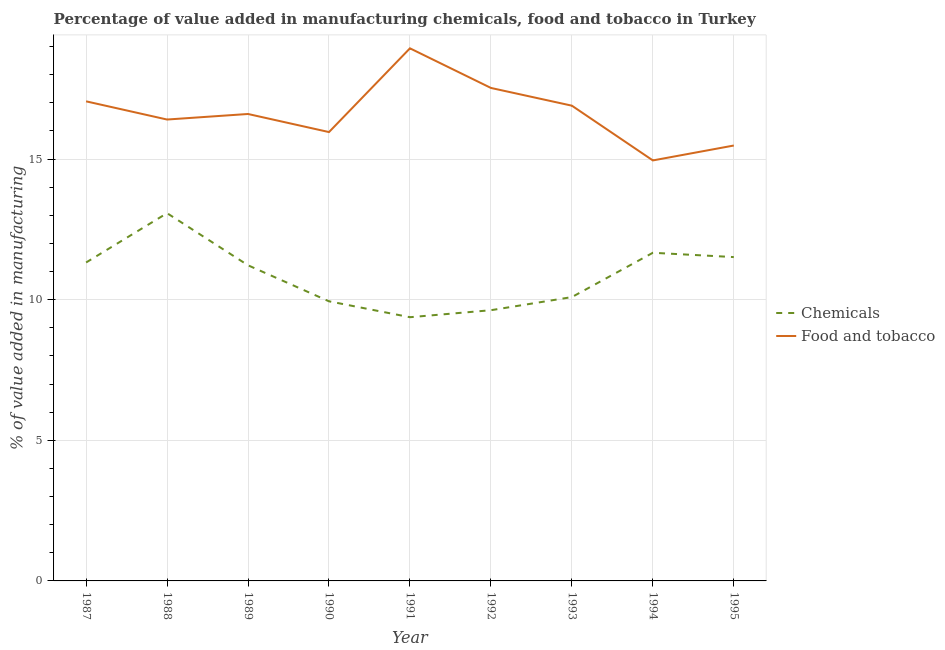Is the number of lines equal to the number of legend labels?
Ensure brevity in your answer.  Yes. What is the value added by manufacturing food and tobacco in 1990?
Your response must be concise. 15.96. Across all years, what is the maximum value added by manufacturing food and tobacco?
Make the answer very short. 18.94. Across all years, what is the minimum value added by manufacturing food and tobacco?
Make the answer very short. 14.95. In which year was the value added by  manufacturing chemicals maximum?
Your answer should be very brief. 1988. What is the total value added by  manufacturing chemicals in the graph?
Make the answer very short. 97.83. What is the difference between the value added by manufacturing food and tobacco in 1994 and that in 1995?
Ensure brevity in your answer.  -0.53. What is the difference between the value added by  manufacturing chemicals in 1990 and the value added by manufacturing food and tobacco in 1988?
Provide a short and direct response. -6.46. What is the average value added by  manufacturing chemicals per year?
Make the answer very short. 10.87. In the year 1995, what is the difference between the value added by manufacturing food and tobacco and value added by  manufacturing chemicals?
Give a very brief answer. 3.97. In how many years, is the value added by  manufacturing chemicals greater than 9 %?
Your answer should be very brief. 9. What is the ratio of the value added by  manufacturing chemicals in 1993 to that in 1994?
Offer a very short reply. 0.86. Is the value added by manufacturing food and tobacco in 1987 less than that in 1994?
Make the answer very short. No. What is the difference between the highest and the second highest value added by  manufacturing chemicals?
Offer a very short reply. 1.41. What is the difference between the highest and the lowest value added by manufacturing food and tobacco?
Your answer should be compact. 3.99. How many lines are there?
Give a very brief answer. 2. How many years are there in the graph?
Ensure brevity in your answer.  9. What is the difference between two consecutive major ticks on the Y-axis?
Your answer should be compact. 5. Are the values on the major ticks of Y-axis written in scientific E-notation?
Give a very brief answer. No. Does the graph contain grids?
Ensure brevity in your answer.  Yes. Where does the legend appear in the graph?
Give a very brief answer. Center right. How are the legend labels stacked?
Offer a very short reply. Vertical. What is the title of the graph?
Your response must be concise. Percentage of value added in manufacturing chemicals, food and tobacco in Turkey. What is the label or title of the X-axis?
Provide a succinct answer. Year. What is the label or title of the Y-axis?
Ensure brevity in your answer.  % of value added in manufacturing. What is the % of value added in manufacturing of Chemicals in 1987?
Provide a short and direct response. 11.32. What is the % of value added in manufacturing of Food and tobacco in 1987?
Offer a terse response. 17.05. What is the % of value added in manufacturing of Chemicals in 1988?
Ensure brevity in your answer.  13.08. What is the % of value added in manufacturing in Food and tobacco in 1988?
Your response must be concise. 16.4. What is the % of value added in manufacturing of Chemicals in 1989?
Your answer should be very brief. 11.22. What is the % of value added in manufacturing of Food and tobacco in 1989?
Provide a short and direct response. 16.6. What is the % of value added in manufacturing in Chemicals in 1990?
Your answer should be very brief. 9.94. What is the % of value added in manufacturing of Food and tobacco in 1990?
Provide a short and direct response. 15.96. What is the % of value added in manufacturing of Chemicals in 1991?
Offer a very short reply. 9.38. What is the % of value added in manufacturing in Food and tobacco in 1991?
Provide a short and direct response. 18.94. What is the % of value added in manufacturing of Chemicals in 1992?
Offer a very short reply. 9.63. What is the % of value added in manufacturing of Food and tobacco in 1992?
Offer a very short reply. 17.53. What is the % of value added in manufacturing in Chemicals in 1993?
Offer a terse response. 10.09. What is the % of value added in manufacturing in Food and tobacco in 1993?
Give a very brief answer. 16.9. What is the % of value added in manufacturing of Chemicals in 1994?
Give a very brief answer. 11.67. What is the % of value added in manufacturing in Food and tobacco in 1994?
Offer a terse response. 14.95. What is the % of value added in manufacturing of Chemicals in 1995?
Your answer should be very brief. 11.51. What is the % of value added in manufacturing in Food and tobacco in 1995?
Your answer should be compact. 15.48. Across all years, what is the maximum % of value added in manufacturing of Chemicals?
Your response must be concise. 13.08. Across all years, what is the maximum % of value added in manufacturing of Food and tobacco?
Your answer should be very brief. 18.94. Across all years, what is the minimum % of value added in manufacturing of Chemicals?
Ensure brevity in your answer.  9.38. Across all years, what is the minimum % of value added in manufacturing in Food and tobacco?
Your answer should be very brief. 14.95. What is the total % of value added in manufacturing of Chemicals in the graph?
Your response must be concise. 97.83. What is the total % of value added in manufacturing of Food and tobacco in the graph?
Offer a very short reply. 149.81. What is the difference between the % of value added in manufacturing in Chemicals in 1987 and that in 1988?
Your answer should be very brief. -1.75. What is the difference between the % of value added in manufacturing in Food and tobacco in 1987 and that in 1988?
Keep it short and to the point. 0.65. What is the difference between the % of value added in manufacturing of Chemicals in 1987 and that in 1989?
Give a very brief answer. 0.1. What is the difference between the % of value added in manufacturing of Food and tobacco in 1987 and that in 1989?
Provide a short and direct response. 0.45. What is the difference between the % of value added in manufacturing in Chemicals in 1987 and that in 1990?
Ensure brevity in your answer.  1.38. What is the difference between the % of value added in manufacturing in Food and tobacco in 1987 and that in 1990?
Your response must be concise. 1.09. What is the difference between the % of value added in manufacturing in Chemicals in 1987 and that in 1991?
Keep it short and to the point. 1.95. What is the difference between the % of value added in manufacturing in Food and tobacco in 1987 and that in 1991?
Your response must be concise. -1.88. What is the difference between the % of value added in manufacturing in Chemicals in 1987 and that in 1992?
Make the answer very short. 1.7. What is the difference between the % of value added in manufacturing in Food and tobacco in 1987 and that in 1992?
Give a very brief answer. -0.48. What is the difference between the % of value added in manufacturing in Chemicals in 1987 and that in 1993?
Your answer should be compact. 1.23. What is the difference between the % of value added in manufacturing of Food and tobacco in 1987 and that in 1993?
Ensure brevity in your answer.  0.15. What is the difference between the % of value added in manufacturing in Chemicals in 1987 and that in 1994?
Offer a very short reply. -0.35. What is the difference between the % of value added in manufacturing of Food and tobacco in 1987 and that in 1994?
Provide a short and direct response. 2.1. What is the difference between the % of value added in manufacturing of Chemicals in 1987 and that in 1995?
Ensure brevity in your answer.  -0.19. What is the difference between the % of value added in manufacturing in Food and tobacco in 1987 and that in 1995?
Provide a short and direct response. 1.57. What is the difference between the % of value added in manufacturing in Chemicals in 1988 and that in 1989?
Provide a succinct answer. 1.85. What is the difference between the % of value added in manufacturing of Food and tobacco in 1988 and that in 1989?
Offer a very short reply. -0.2. What is the difference between the % of value added in manufacturing of Chemicals in 1988 and that in 1990?
Give a very brief answer. 3.13. What is the difference between the % of value added in manufacturing of Food and tobacco in 1988 and that in 1990?
Offer a very short reply. 0.45. What is the difference between the % of value added in manufacturing of Chemicals in 1988 and that in 1991?
Provide a short and direct response. 3.7. What is the difference between the % of value added in manufacturing of Food and tobacco in 1988 and that in 1991?
Offer a very short reply. -2.53. What is the difference between the % of value added in manufacturing in Chemicals in 1988 and that in 1992?
Ensure brevity in your answer.  3.45. What is the difference between the % of value added in manufacturing of Food and tobacco in 1988 and that in 1992?
Provide a succinct answer. -1.12. What is the difference between the % of value added in manufacturing of Chemicals in 1988 and that in 1993?
Ensure brevity in your answer.  2.98. What is the difference between the % of value added in manufacturing of Food and tobacco in 1988 and that in 1993?
Your answer should be compact. -0.49. What is the difference between the % of value added in manufacturing of Chemicals in 1988 and that in 1994?
Keep it short and to the point. 1.41. What is the difference between the % of value added in manufacturing in Food and tobacco in 1988 and that in 1994?
Offer a very short reply. 1.45. What is the difference between the % of value added in manufacturing in Chemicals in 1988 and that in 1995?
Offer a very short reply. 1.56. What is the difference between the % of value added in manufacturing in Food and tobacco in 1988 and that in 1995?
Offer a very short reply. 0.92. What is the difference between the % of value added in manufacturing of Chemicals in 1989 and that in 1990?
Your answer should be compact. 1.28. What is the difference between the % of value added in manufacturing of Food and tobacco in 1989 and that in 1990?
Keep it short and to the point. 0.64. What is the difference between the % of value added in manufacturing of Chemicals in 1989 and that in 1991?
Offer a terse response. 1.85. What is the difference between the % of value added in manufacturing of Food and tobacco in 1989 and that in 1991?
Keep it short and to the point. -2.33. What is the difference between the % of value added in manufacturing in Chemicals in 1989 and that in 1992?
Your response must be concise. 1.6. What is the difference between the % of value added in manufacturing of Food and tobacco in 1989 and that in 1992?
Give a very brief answer. -0.93. What is the difference between the % of value added in manufacturing of Chemicals in 1989 and that in 1993?
Provide a short and direct response. 1.13. What is the difference between the % of value added in manufacturing in Food and tobacco in 1989 and that in 1993?
Keep it short and to the point. -0.3. What is the difference between the % of value added in manufacturing of Chemicals in 1989 and that in 1994?
Provide a succinct answer. -0.45. What is the difference between the % of value added in manufacturing of Food and tobacco in 1989 and that in 1994?
Make the answer very short. 1.65. What is the difference between the % of value added in manufacturing in Chemicals in 1989 and that in 1995?
Ensure brevity in your answer.  -0.29. What is the difference between the % of value added in manufacturing in Food and tobacco in 1989 and that in 1995?
Give a very brief answer. 1.12. What is the difference between the % of value added in manufacturing in Chemicals in 1990 and that in 1991?
Provide a short and direct response. 0.57. What is the difference between the % of value added in manufacturing of Food and tobacco in 1990 and that in 1991?
Make the answer very short. -2.98. What is the difference between the % of value added in manufacturing in Chemicals in 1990 and that in 1992?
Provide a succinct answer. 0.32. What is the difference between the % of value added in manufacturing of Food and tobacco in 1990 and that in 1992?
Provide a succinct answer. -1.57. What is the difference between the % of value added in manufacturing in Chemicals in 1990 and that in 1993?
Your response must be concise. -0.15. What is the difference between the % of value added in manufacturing of Food and tobacco in 1990 and that in 1993?
Provide a short and direct response. -0.94. What is the difference between the % of value added in manufacturing in Chemicals in 1990 and that in 1994?
Provide a short and direct response. -1.73. What is the difference between the % of value added in manufacturing of Food and tobacco in 1990 and that in 1994?
Your answer should be very brief. 1.01. What is the difference between the % of value added in manufacturing of Chemicals in 1990 and that in 1995?
Offer a very short reply. -1.57. What is the difference between the % of value added in manufacturing in Food and tobacco in 1990 and that in 1995?
Your response must be concise. 0.48. What is the difference between the % of value added in manufacturing of Chemicals in 1991 and that in 1992?
Keep it short and to the point. -0.25. What is the difference between the % of value added in manufacturing of Food and tobacco in 1991 and that in 1992?
Provide a short and direct response. 1.41. What is the difference between the % of value added in manufacturing in Chemicals in 1991 and that in 1993?
Give a very brief answer. -0.72. What is the difference between the % of value added in manufacturing of Food and tobacco in 1991 and that in 1993?
Offer a terse response. 2.04. What is the difference between the % of value added in manufacturing of Chemicals in 1991 and that in 1994?
Give a very brief answer. -2.29. What is the difference between the % of value added in manufacturing in Food and tobacco in 1991 and that in 1994?
Keep it short and to the point. 3.99. What is the difference between the % of value added in manufacturing in Chemicals in 1991 and that in 1995?
Ensure brevity in your answer.  -2.14. What is the difference between the % of value added in manufacturing in Food and tobacco in 1991 and that in 1995?
Ensure brevity in your answer.  3.46. What is the difference between the % of value added in manufacturing in Chemicals in 1992 and that in 1993?
Keep it short and to the point. -0.47. What is the difference between the % of value added in manufacturing in Food and tobacco in 1992 and that in 1993?
Offer a very short reply. 0.63. What is the difference between the % of value added in manufacturing in Chemicals in 1992 and that in 1994?
Make the answer very short. -2.04. What is the difference between the % of value added in manufacturing in Food and tobacco in 1992 and that in 1994?
Provide a short and direct response. 2.58. What is the difference between the % of value added in manufacturing of Chemicals in 1992 and that in 1995?
Provide a short and direct response. -1.89. What is the difference between the % of value added in manufacturing in Food and tobacco in 1992 and that in 1995?
Provide a short and direct response. 2.05. What is the difference between the % of value added in manufacturing of Chemicals in 1993 and that in 1994?
Your response must be concise. -1.58. What is the difference between the % of value added in manufacturing of Food and tobacco in 1993 and that in 1994?
Ensure brevity in your answer.  1.95. What is the difference between the % of value added in manufacturing in Chemicals in 1993 and that in 1995?
Offer a very short reply. -1.42. What is the difference between the % of value added in manufacturing of Food and tobacco in 1993 and that in 1995?
Offer a terse response. 1.42. What is the difference between the % of value added in manufacturing of Chemicals in 1994 and that in 1995?
Provide a succinct answer. 0.15. What is the difference between the % of value added in manufacturing of Food and tobacco in 1994 and that in 1995?
Give a very brief answer. -0.53. What is the difference between the % of value added in manufacturing of Chemicals in 1987 and the % of value added in manufacturing of Food and tobacco in 1988?
Keep it short and to the point. -5.08. What is the difference between the % of value added in manufacturing in Chemicals in 1987 and the % of value added in manufacturing in Food and tobacco in 1989?
Ensure brevity in your answer.  -5.28. What is the difference between the % of value added in manufacturing in Chemicals in 1987 and the % of value added in manufacturing in Food and tobacco in 1990?
Provide a succinct answer. -4.64. What is the difference between the % of value added in manufacturing in Chemicals in 1987 and the % of value added in manufacturing in Food and tobacco in 1991?
Your response must be concise. -7.61. What is the difference between the % of value added in manufacturing of Chemicals in 1987 and the % of value added in manufacturing of Food and tobacco in 1992?
Provide a short and direct response. -6.21. What is the difference between the % of value added in manufacturing in Chemicals in 1987 and the % of value added in manufacturing in Food and tobacco in 1993?
Offer a terse response. -5.57. What is the difference between the % of value added in manufacturing of Chemicals in 1987 and the % of value added in manufacturing of Food and tobacco in 1994?
Your answer should be compact. -3.63. What is the difference between the % of value added in manufacturing in Chemicals in 1987 and the % of value added in manufacturing in Food and tobacco in 1995?
Offer a terse response. -4.16. What is the difference between the % of value added in manufacturing in Chemicals in 1988 and the % of value added in manufacturing in Food and tobacco in 1989?
Keep it short and to the point. -3.53. What is the difference between the % of value added in manufacturing in Chemicals in 1988 and the % of value added in manufacturing in Food and tobacco in 1990?
Keep it short and to the point. -2.88. What is the difference between the % of value added in manufacturing of Chemicals in 1988 and the % of value added in manufacturing of Food and tobacco in 1991?
Offer a very short reply. -5.86. What is the difference between the % of value added in manufacturing in Chemicals in 1988 and the % of value added in manufacturing in Food and tobacco in 1992?
Provide a short and direct response. -4.45. What is the difference between the % of value added in manufacturing in Chemicals in 1988 and the % of value added in manufacturing in Food and tobacco in 1993?
Offer a terse response. -3.82. What is the difference between the % of value added in manufacturing in Chemicals in 1988 and the % of value added in manufacturing in Food and tobacco in 1994?
Ensure brevity in your answer.  -1.88. What is the difference between the % of value added in manufacturing in Chemicals in 1988 and the % of value added in manufacturing in Food and tobacco in 1995?
Offer a terse response. -2.41. What is the difference between the % of value added in manufacturing of Chemicals in 1989 and the % of value added in manufacturing of Food and tobacco in 1990?
Give a very brief answer. -4.74. What is the difference between the % of value added in manufacturing in Chemicals in 1989 and the % of value added in manufacturing in Food and tobacco in 1991?
Offer a terse response. -7.71. What is the difference between the % of value added in manufacturing in Chemicals in 1989 and the % of value added in manufacturing in Food and tobacco in 1992?
Offer a very short reply. -6.31. What is the difference between the % of value added in manufacturing in Chemicals in 1989 and the % of value added in manufacturing in Food and tobacco in 1993?
Offer a terse response. -5.67. What is the difference between the % of value added in manufacturing of Chemicals in 1989 and the % of value added in manufacturing of Food and tobacco in 1994?
Keep it short and to the point. -3.73. What is the difference between the % of value added in manufacturing in Chemicals in 1989 and the % of value added in manufacturing in Food and tobacco in 1995?
Make the answer very short. -4.26. What is the difference between the % of value added in manufacturing of Chemicals in 1990 and the % of value added in manufacturing of Food and tobacco in 1991?
Provide a short and direct response. -8.99. What is the difference between the % of value added in manufacturing in Chemicals in 1990 and the % of value added in manufacturing in Food and tobacco in 1992?
Your response must be concise. -7.59. What is the difference between the % of value added in manufacturing in Chemicals in 1990 and the % of value added in manufacturing in Food and tobacco in 1993?
Your answer should be compact. -6.96. What is the difference between the % of value added in manufacturing in Chemicals in 1990 and the % of value added in manufacturing in Food and tobacco in 1994?
Your answer should be very brief. -5.01. What is the difference between the % of value added in manufacturing in Chemicals in 1990 and the % of value added in manufacturing in Food and tobacco in 1995?
Offer a very short reply. -5.54. What is the difference between the % of value added in manufacturing in Chemicals in 1991 and the % of value added in manufacturing in Food and tobacco in 1992?
Your response must be concise. -8.15. What is the difference between the % of value added in manufacturing in Chemicals in 1991 and the % of value added in manufacturing in Food and tobacco in 1993?
Give a very brief answer. -7.52. What is the difference between the % of value added in manufacturing of Chemicals in 1991 and the % of value added in manufacturing of Food and tobacco in 1994?
Provide a short and direct response. -5.57. What is the difference between the % of value added in manufacturing in Chemicals in 1991 and the % of value added in manufacturing in Food and tobacco in 1995?
Keep it short and to the point. -6.1. What is the difference between the % of value added in manufacturing of Chemicals in 1992 and the % of value added in manufacturing of Food and tobacco in 1993?
Make the answer very short. -7.27. What is the difference between the % of value added in manufacturing of Chemicals in 1992 and the % of value added in manufacturing of Food and tobacco in 1994?
Your answer should be very brief. -5.33. What is the difference between the % of value added in manufacturing of Chemicals in 1992 and the % of value added in manufacturing of Food and tobacco in 1995?
Ensure brevity in your answer.  -5.86. What is the difference between the % of value added in manufacturing of Chemicals in 1993 and the % of value added in manufacturing of Food and tobacco in 1994?
Provide a succinct answer. -4.86. What is the difference between the % of value added in manufacturing of Chemicals in 1993 and the % of value added in manufacturing of Food and tobacco in 1995?
Make the answer very short. -5.39. What is the difference between the % of value added in manufacturing of Chemicals in 1994 and the % of value added in manufacturing of Food and tobacco in 1995?
Offer a terse response. -3.81. What is the average % of value added in manufacturing in Chemicals per year?
Provide a short and direct response. 10.87. What is the average % of value added in manufacturing of Food and tobacco per year?
Your response must be concise. 16.65. In the year 1987, what is the difference between the % of value added in manufacturing in Chemicals and % of value added in manufacturing in Food and tobacco?
Your response must be concise. -5.73. In the year 1988, what is the difference between the % of value added in manufacturing of Chemicals and % of value added in manufacturing of Food and tobacco?
Ensure brevity in your answer.  -3.33. In the year 1989, what is the difference between the % of value added in manufacturing of Chemicals and % of value added in manufacturing of Food and tobacco?
Give a very brief answer. -5.38. In the year 1990, what is the difference between the % of value added in manufacturing of Chemicals and % of value added in manufacturing of Food and tobacco?
Provide a succinct answer. -6.02. In the year 1991, what is the difference between the % of value added in manufacturing of Chemicals and % of value added in manufacturing of Food and tobacco?
Give a very brief answer. -9.56. In the year 1992, what is the difference between the % of value added in manufacturing of Chemicals and % of value added in manufacturing of Food and tobacco?
Offer a very short reply. -7.9. In the year 1993, what is the difference between the % of value added in manufacturing in Chemicals and % of value added in manufacturing in Food and tobacco?
Give a very brief answer. -6.8. In the year 1994, what is the difference between the % of value added in manufacturing in Chemicals and % of value added in manufacturing in Food and tobacco?
Your answer should be compact. -3.28. In the year 1995, what is the difference between the % of value added in manufacturing in Chemicals and % of value added in manufacturing in Food and tobacco?
Your answer should be very brief. -3.97. What is the ratio of the % of value added in manufacturing of Chemicals in 1987 to that in 1988?
Keep it short and to the point. 0.87. What is the ratio of the % of value added in manufacturing in Food and tobacco in 1987 to that in 1988?
Offer a very short reply. 1.04. What is the ratio of the % of value added in manufacturing in Chemicals in 1987 to that in 1989?
Your answer should be compact. 1.01. What is the ratio of the % of value added in manufacturing of Food and tobacco in 1987 to that in 1989?
Give a very brief answer. 1.03. What is the ratio of the % of value added in manufacturing of Chemicals in 1987 to that in 1990?
Make the answer very short. 1.14. What is the ratio of the % of value added in manufacturing of Food and tobacco in 1987 to that in 1990?
Keep it short and to the point. 1.07. What is the ratio of the % of value added in manufacturing in Chemicals in 1987 to that in 1991?
Your answer should be compact. 1.21. What is the ratio of the % of value added in manufacturing of Food and tobacco in 1987 to that in 1991?
Give a very brief answer. 0.9. What is the ratio of the % of value added in manufacturing of Chemicals in 1987 to that in 1992?
Keep it short and to the point. 1.18. What is the ratio of the % of value added in manufacturing of Food and tobacco in 1987 to that in 1992?
Your answer should be compact. 0.97. What is the ratio of the % of value added in manufacturing of Chemicals in 1987 to that in 1993?
Keep it short and to the point. 1.12. What is the ratio of the % of value added in manufacturing in Food and tobacco in 1987 to that in 1993?
Your answer should be compact. 1.01. What is the ratio of the % of value added in manufacturing in Chemicals in 1987 to that in 1994?
Ensure brevity in your answer.  0.97. What is the ratio of the % of value added in manufacturing of Food and tobacco in 1987 to that in 1994?
Your answer should be very brief. 1.14. What is the ratio of the % of value added in manufacturing of Chemicals in 1987 to that in 1995?
Give a very brief answer. 0.98. What is the ratio of the % of value added in manufacturing of Food and tobacco in 1987 to that in 1995?
Provide a succinct answer. 1.1. What is the ratio of the % of value added in manufacturing in Chemicals in 1988 to that in 1989?
Keep it short and to the point. 1.17. What is the ratio of the % of value added in manufacturing of Chemicals in 1988 to that in 1990?
Ensure brevity in your answer.  1.32. What is the ratio of the % of value added in manufacturing in Food and tobacco in 1988 to that in 1990?
Your answer should be compact. 1.03. What is the ratio of the % of value added in manufacturing of Chemicals in 1988 to that in 1991?
Offer a very short reply. 1.39. What is the ratio of the % of value added in manufacturing in Food and tobacco in 1988 to that in 1991?
Make the answer very short. 0.87. What is the ratio of the % of value added in manufacturing of Chemicals in 1988 to that in 1992?
Offer a terse response. 1.36. What is the ratio of the % of value added in manufacturing of Food and tobacco in 1988 to that in 1992?
Your response must be concise. 0.94. What is the ratio of the % of value added in manufacturing of Chemicals in 1988 to that in 1993?
Make the answer very short. 1.3. What is the ratio of the % of value added in manufacturing in Food and tobacco in 1988 to that in 1993?
Your response must be concise. 0.97. What is the ratio of the % of value added in manufacturing of Chemicals in 1988 to that in 1994?
Provide a short and direct response. 1.12. What is the ratio of the % of value added in manufacturing of Food and tobacco in 1988 to that in 1994?
Your response must be concise. 1.1. What is the ratio of the % of value added in manufacturing of Chemicals in 1988 to that in 1995?
Ensure brevity in your answer.  1.14. What is the ratio of the % of value added in manufacturing of Food and tobacco in 1988 to that in 1995?
Your response must be concise. 1.06. What is the ratio of the % of value added in manufacturing in Chemicals in 1989 to that in 1990?
Give a very brief answer. 1.13. What is the ratio of the % of value added in manufacturing of Food and tobacco in 1989 to that in 1990?
Offer a very short reply. 1.04. What is the ratio of the % of value added in manufacturing of Chemicals in 1989 to that in 1991?
Your response must be concise. 1.2. What is the ratio of the % of value added in manufacturing of Food and tobacco in 1989 to that in 1991?
Your answer should be compact. 0.88. What is the ratio of the % of value added in manufacturing in Chemicals in 1989 to that in 1992?
Make the answer very short. 1.17. What is the ratio of the % of value added in manufacturing in Food and tobacco in 1989 to that in 1992?
Your response must be concise. 0.95. What is the ratio of the % of value added in manufacturing in Chemicals in 1989 to that in 1993?
Provide a succinct answer. 1.11. What is the ratio of the % of value added in manufacturing in Food and tobacco in 1989 to that in 1993?
Offer a terse response. 0.98. What is the ratio of the % of value added in manufacturing in Chemicals in 1989 to that in 1994?
Your response must be concise. 0.96. What is the ratio of the % of value added in manufacturing in Food and tobacco in 1989 to that in 1994?
Make the answer very short. 1.11. What is the ratio of the % of value added in manufacturing of Chemicals in 1989 to that in 1995?
Your response must be concise. 0.97. What is the ratio of the % of value added in manufacturing in Food and tobacco in 1989 to that in 1995?
Offer a terse response. 1.07. What is the ratio of the % of value added in manufacturing of Chemicals in 1990 to that in 1991?
Provide a succinct answer. 1.06. What is the ratio of the % of value added in manufacturing of Food and tobacco in 1990 to that in 1991?
Offer a very short reply. 0.84. What is the ratio of the % of value added in manufacturing of Chemicals in 1990 to that in 1992?
Offer a terse response. 1.03. What is the ratio of the % of value added in manufacturing in Food and tobacco in 1990 to that in 1992?
Your answer should be very brief. 0.91. What is the ratio of the % of value added in manufacturing of Chemicals in 1990 to that in 1993?
Your answer should be very brief. 0.99. What is the ratio of the % of value added in manufacturing in Food and tobacco in 1990 to that in 1993?
Offer a very short reply. 0.94. What is the ratio of the % of value added in manufacturing in Chemicals in 1990 to that in 1994?
Your answer should be compact. 0.85. What is the ratio of the % of value added in manufacturing of Food and tobacco in 1990 to that in 1994?
Offer a very short reply. 1.07. What is the ratio of the % of value added in manufacturing of Chemicals in 1990 to that in 1995?
Provide a short and direct response. 0.86. What is the ratio of the % of value added in manufacturing of Food and tobacco in 1990 to that in 1995?
Make the answer very short. 1.03. What is the ratio of the % of value added in manufacturing of Chemicals in 1991 to that in 1992?
Make the answer very short. 0.97. What is the ratio of the % of value added in manufacturing of Food and tobacco in 1991 to that in 1992?
Give a very brief answer. 1.08. What is the ratio of the % of value added in manufacturing of Chemicals in 1991 to that in 1993?
Keep it short and to the point. 0.93. What is the ratio of the % of value added in manufacturing of Food and tobacco in 1991 to that in 1993?
Make the answer very short. 1.12. What is the ratio of the % of value added in manufacturing of Chemicals in 1991 to that in 1994?
Provide a succinct answer. 0.8. What is the ratio of the % of value added in manufacturing in Food and tobacco in 1991 to that in 1994?
Your response must be concise. 1.27. What is the ratio of the % of value added in manufacturing in Chemicals in 1991 to that in 1995?
Offer a very short reply. 0.81. What is the ratio of the % of value added in manufacturing in Food and tobacco in 1991 to that in 1995?
Offer a terse response. 1.22. What is the ratio of the % of value added in manufacturing in Chemicals in 1992 to that in 1993?
Give a very brief answer. 0.95. What is the ratio of the % of value added in manufacturing of Food and tobacco in 1992 to that in 1993?
Your answer should be very brief. 1.04. What is the ratio of the % of value added in manufacturing in Chemicals in 1992 to that in 1994?
Give a very brief answer. 0.82. What is the ratio of the % of value added in manufacturing of Food and tobacco in 1992 to that in 1994?
Make the answer very short. 1.17. What is the ratio of the % of value added in manufacturing in Chemicals in 1992 to that in 1995?
Offer a terse response. 0.84. What is the ratio of the % of value added in manufacturing of Food and tobacco in 1992 to that in 1995?
Offer a very short reply. 1.13. What is the ratio of the % of value added in manufacturing of Chemicals in 1993 to that in 1994?
Keep it short and to the point. 0.86. What is the ratio of the % of value added in manufacturing in Food and tobacco in 1993 to that in 1994?
Keep it short and to the point. 1.13. What is the ratio of the % of value added in manufacturing of Chemicals in 1993 to that in 1995?
Offer a very short reply. 0.88. What is the ratio of the % of value added in manufacturing in Food and tobacco in 1993 to that in 1995?
Offer a terse response. 1.09. What is the ratio of the % of value added in manufacturing in Chemicals in 1994 to that in 1995?
Ensure brevity in your answer.  1.01. What is the ratio of the % of value added in manufacturing of Food and tobacco in 1994 to that in 1995?
Keep it short and to the point. 0.97. What is the difference between the highest and the second highest % of value added in manufacturing in Chemicals?
Offer a very short reply. 1.41. What is the difference between the highest and the second highest % of value added in manufacturing in Food and tobacco?
Ensure brevity in your answer.  1.41. What is the difference between the highest and the lowest % of value added in manufacturing of Chemicals?
Ensure brevity in your answer.  3.7. What is the difference between the highest and the lowest % of value added in manufacturing of Food and tobacco?
Provide a succinct answer. 3.99. 